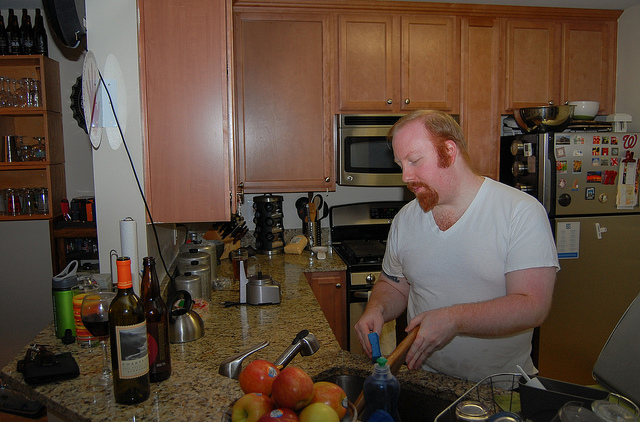What can you say about the kitchen's decor? The kitchen features warm wood cabinetry with a light brown countertop. There are modern appliances, including a coffee maker and a toaster, along with a selection of wine bottles, suggesting that this is a well-equipped space that caters to both cooking and entertainment needs. 